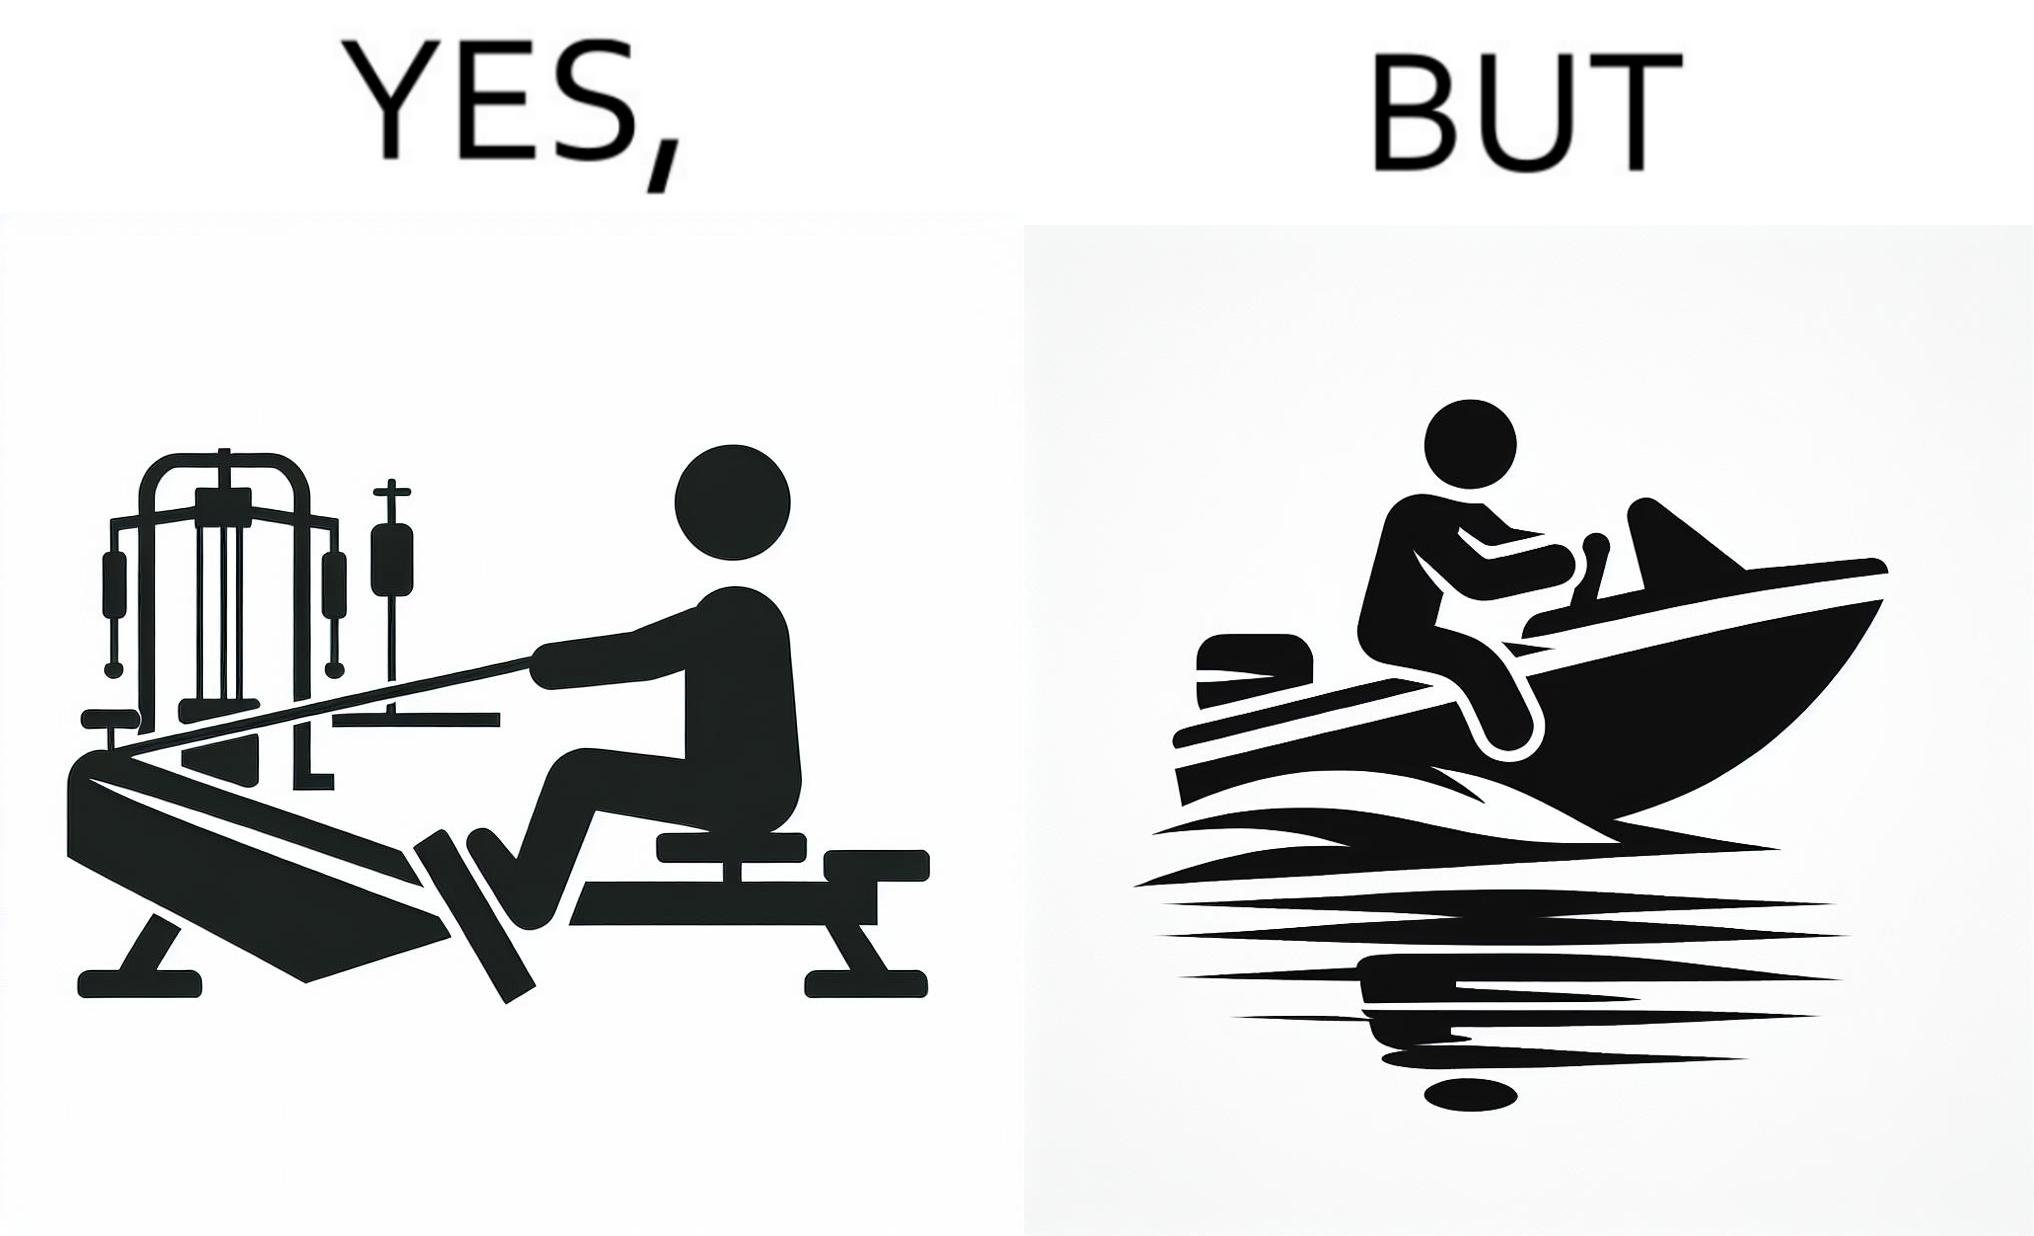Is this a satirical image? Yes, this image is satirical. 